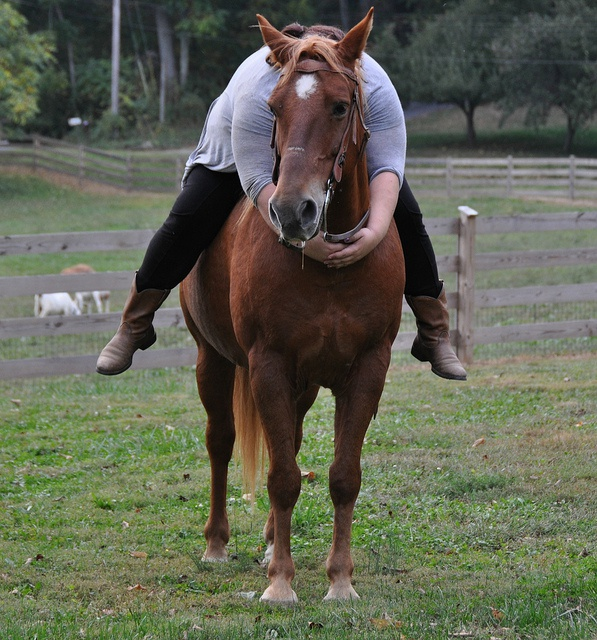Describe the objects in this image and their specific colors. I can see horse in gray, black, and maroon tones and people in gray, black, darkgray, and lavender tones in this image. 